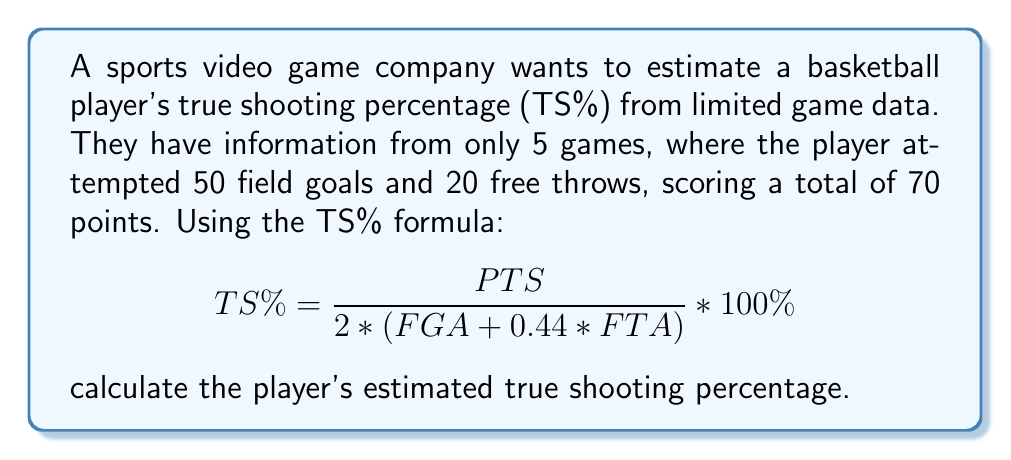Can you solve this math problem? To solve this problem, we'll follow these steps:

1. Identify the given information:
   - Total points (PTS) = 70
   - Field goal attempts (FGA) = 50
   - Free throw attempts (FTA) = 20

2. Apply the TS% formula:
   $$ TS\% = \frac{PTS}{2 * (FGA + 0.44 * FTA)} * 100\% $$

3. Substitute the values into the formula:
   $$ TS\% = \frac{70}{2 * (50 + 0.44 * 20)} * 100\% $$

4. Calculate the denominator:
   $$ 2 * (50 + 0.44 * 20) = 2 * (50 + 8.8) = 2 * 58.8 = 117.6 $$

5. Divide the points by the calculated denominator:
   $$ TS\% = \frac{70}{117.6} * 100\% $$

6. Perform the division:
   $$ TS\% = 0.5952 * 100\% = 59.52\% $$

7. Round to two decimal places:
   $$ TS\% = 59.52\% $$
Answer: 59.52% 